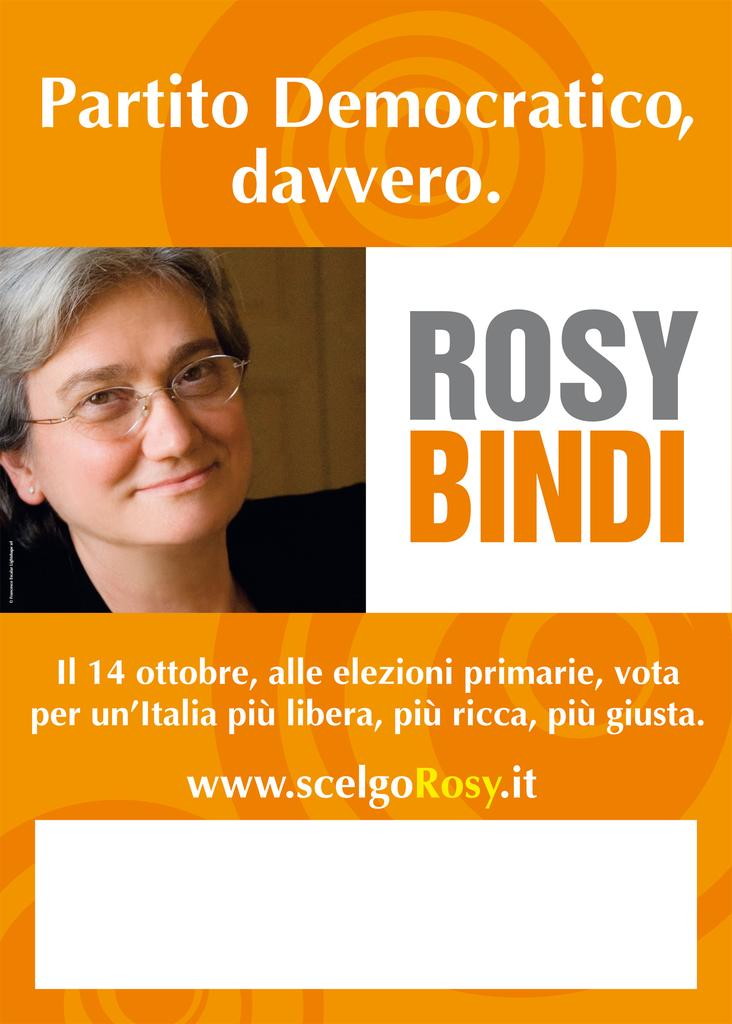What type of visual is shown in the image? The image is a poster. Who or what is featured on the poster? There is a person depicted on the poster. Are there any words or phrases on the poster? Yes, there is writing on the poster. What type of mountain is visible in the background of the poster? There is no mountain visible in the image, as it is a poster featuring a person and writing. 